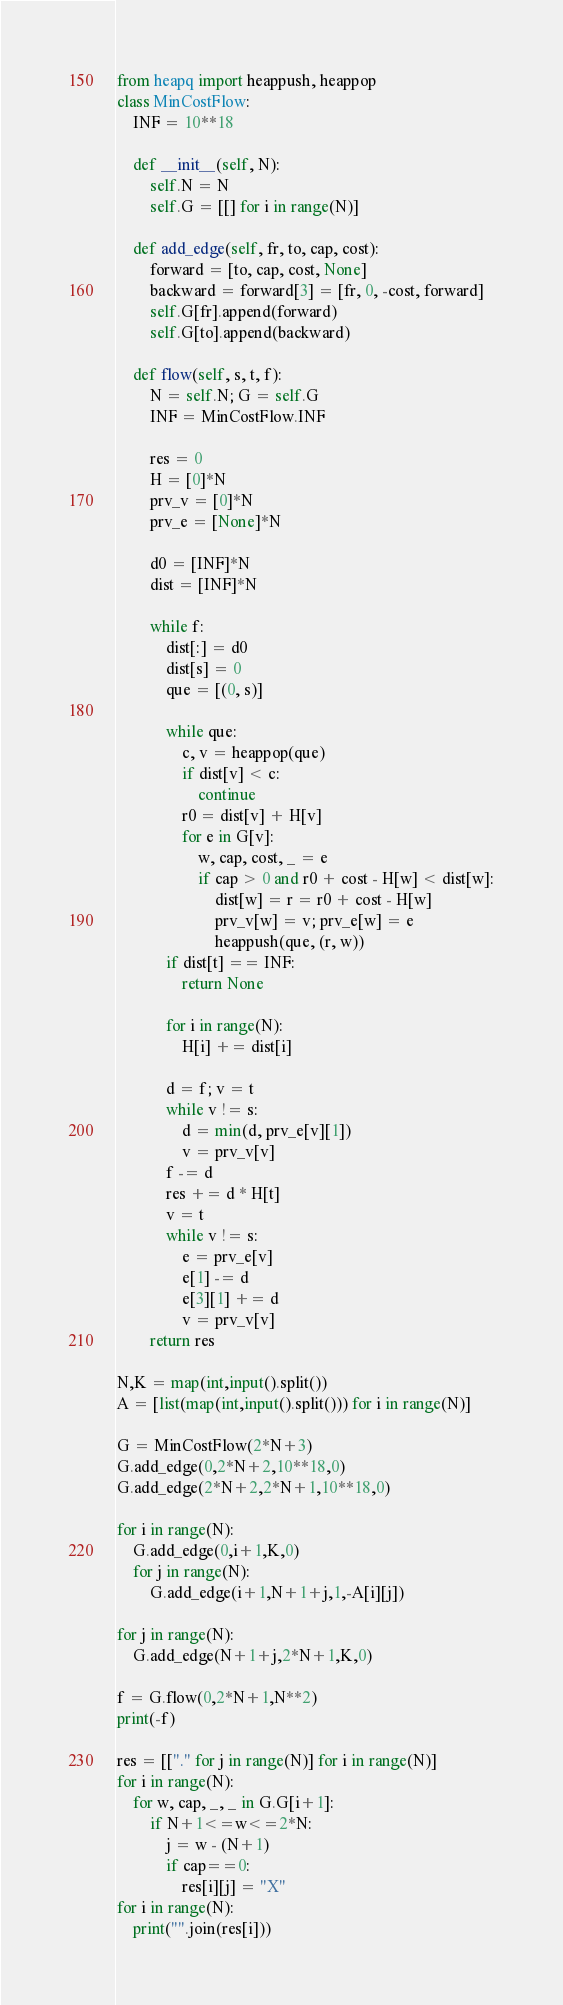Convert code to text. <code><loc_0><loc_0><loc_500><loc_500><_Python_>from heapq import heappush, heappop
class MinCostFlow:
    INF = 10**18

    def __init__(self, N):
        self.N = N
        self.G = [[] for i in range(N)]

    def add_edge(self, fr, to, cap, cost):
        forward = [to, cap, cost, None]
        backward = forward[3] = [fr, 0, -cost, forward]
        self.G[fr].append(forward)
        self.G[to].append(backward)

    def flow(self, s, t, f):
        N = self.N; G = self.G
        INF = MinCostFlow.INF

        res = 0
        H = [0]*N
        prv_v = [0]*N
        prv_e = [None]*N

        d0 = [INF]*N
        dist = [INF]*N

        while f:
            dist[:] = d0
            dist[s] = 0
            que = [(0, s)]

            while que:
                c, v = heappop(que)
                if dist[v] < c:
                    continue
                r0 = dist[v] + H[v]
                for e in G[v]:
                    w, cap, cost, _ = e
                    if cap > 0 and r0 + cost - H[w] < dist[w]:
                        dist[w] = r = r0 + cost - H[w]
                        prv_v[w] = v; prv_e[w] = e
                        heappush(que, (r, w))
            if dist[t] == INF:
                return None

            for i in range(N):
                H[i] += dist[i]

            d = f; v = t
            while v != s:
                d = min(d, prv_e[v][1])
                v = prv_v[v]
            f -= d
            res += d * H[t]
            v = t
            while v != s:
                e = prv_e[v]
                e[1] -= d
                e[3][1] += d
                v = prv_v[v]
        return res

N,K = map(int,input().split())
A = [list(map(int,input().split())) for i in range(N)]

G = MinCostFlow(2*N+3)
G.add_edge(0,2*N+2,10**18,0)
G.add_edge(2*N+2,2*N+1,10**18,0)

for i in range(N):
    G.add_edge(0,i+1,K,0)
    for j in range(N):
        G.add_edge(i+1,N+1+j,1,-A[i][j])

for j in range(N):
    G.add_edge(N+1+j,2*N+1,K,0)

f = G.flow(0,2*N+1,N**2)
print(-f)

res = [["." for j in range(N)] for i in range(N)]
for i in range(N):
    for w, cap, _, _ in G.G[i+1]:
        if N+1<=w<=2*N:
            j = w - (N+1)
            if cap==0:
                res[i][j] = "X"
for i in range(N):
    print("".join(res[i]))
</code> 